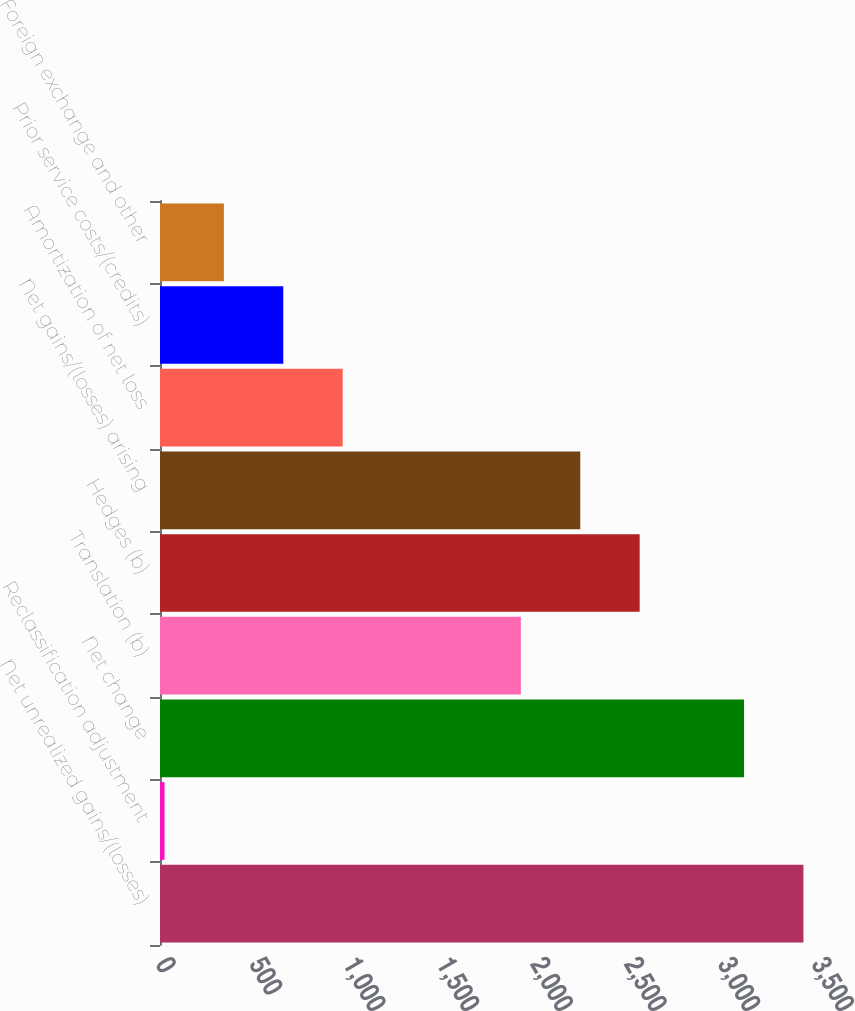<chart> <loc_0><loc_0><loc_500><loc_500><bar_chart><fcel>Net unrealized gains/(losses)<fcel>Reclassification adjustment<fcel>Net change<fcel>Translation (b)<fcel>Hedges (b)<fcel>Net gains/(losses) arising<fcel>Amortization of net loss<fcel>Prior service costs/(credits)<fcel>Foreign exchange and other<nl><fcel>3432.9<fcel>24<fcel>3116<fcel>1925.4<fcel>2559.2<fcel>2242.3<fcel>974.7<fcel>657.8<fcel>340.9<nl></chart> 